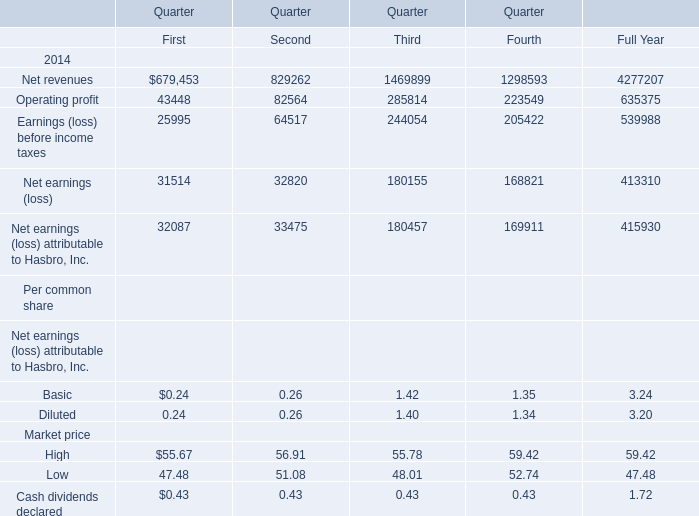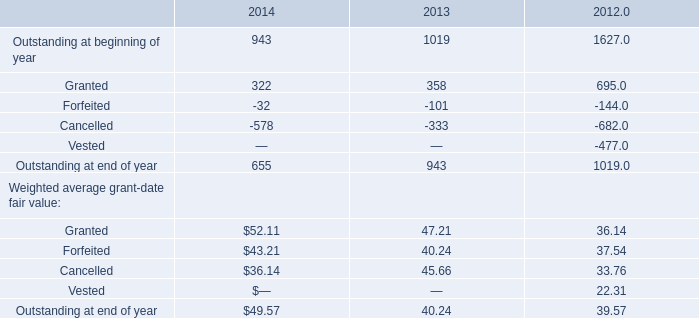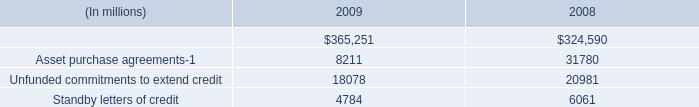In the quarter of 2014 with highest Operating profit, what's the sum of Net revenues? 
Answer: 1469899. 